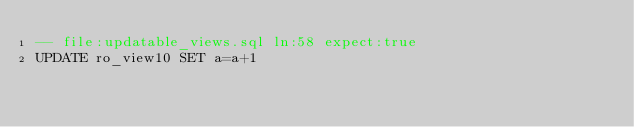Convert code to text. <code><loc_0><loc_0><loc_500><loc_500><_SQL_>-- file:updatable_views.sql ln:58 expect:true
UPDATE ro_view10 SET a=a+1
</code> 